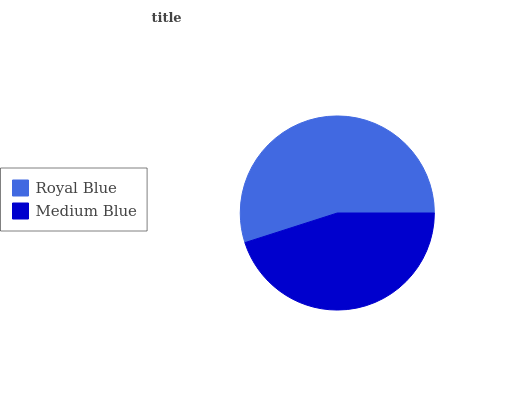Is Medium Blue the minimum?
Answer yes or no. Yes. Is Royal Blue the maximum?
Answer yes or no. Yes. Is Medium Blue the maximum?
Answer yes or no. No. Is Royal Blue greater than Medium Blue?
Answer yes or no. Yes. Is Medium Blue less than Royal Blue?
Answer yes or no. Yes. Is Medium Blue greater than Royal Blue?
Answer yes or no. No. Is Royal Blue less than Medium Blue?
Answer yes or no. No. Is Royal Blue the high median?
Answer yes or no. Yes. Is Medium Blue the low median?
Answer yes or no. Yes. Is Medium Blue the high median?
Answer yes or no. No. Is Royal Blue the low median?
Answer yes or no. No. 